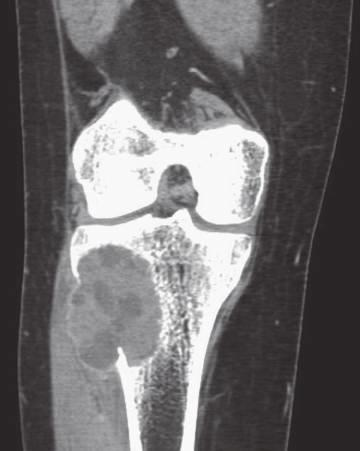s section compute axial tomography scan showing eccentric aneurysmal bone cyst of tibia?
Answer the question using a single word or phrase. No 